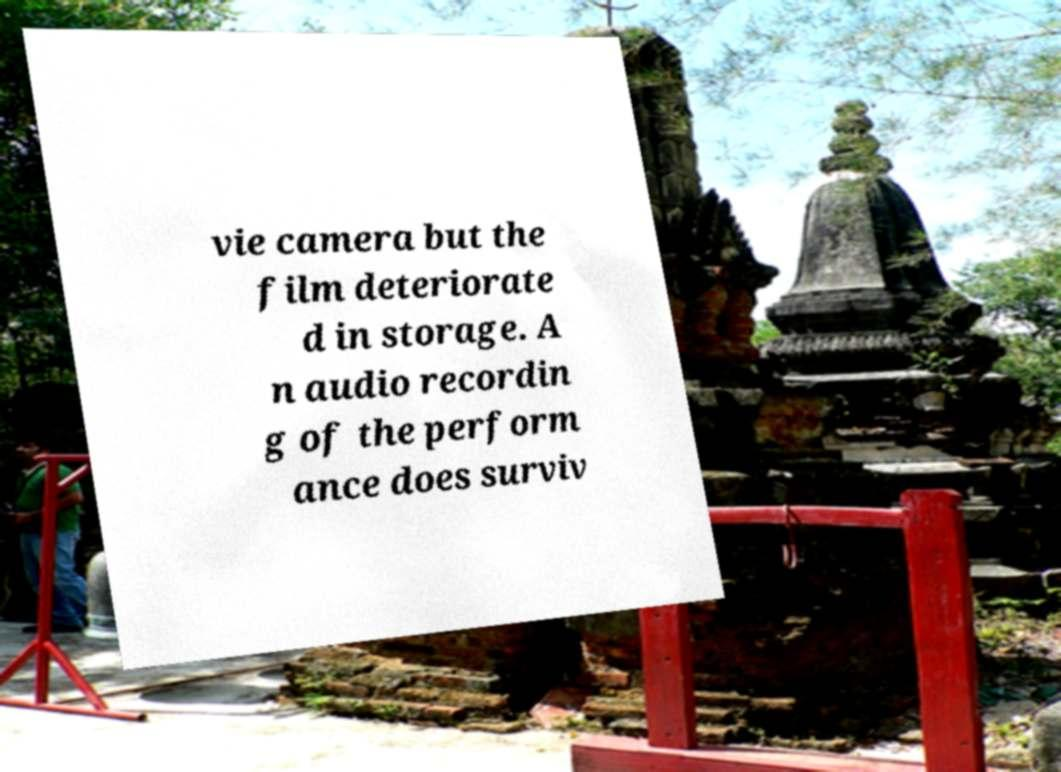I need the written content from this picture converted into text. Can you do that? vie camera but the film deteriorate d in storage. A n audio recordin g of the perform ance does surviv 